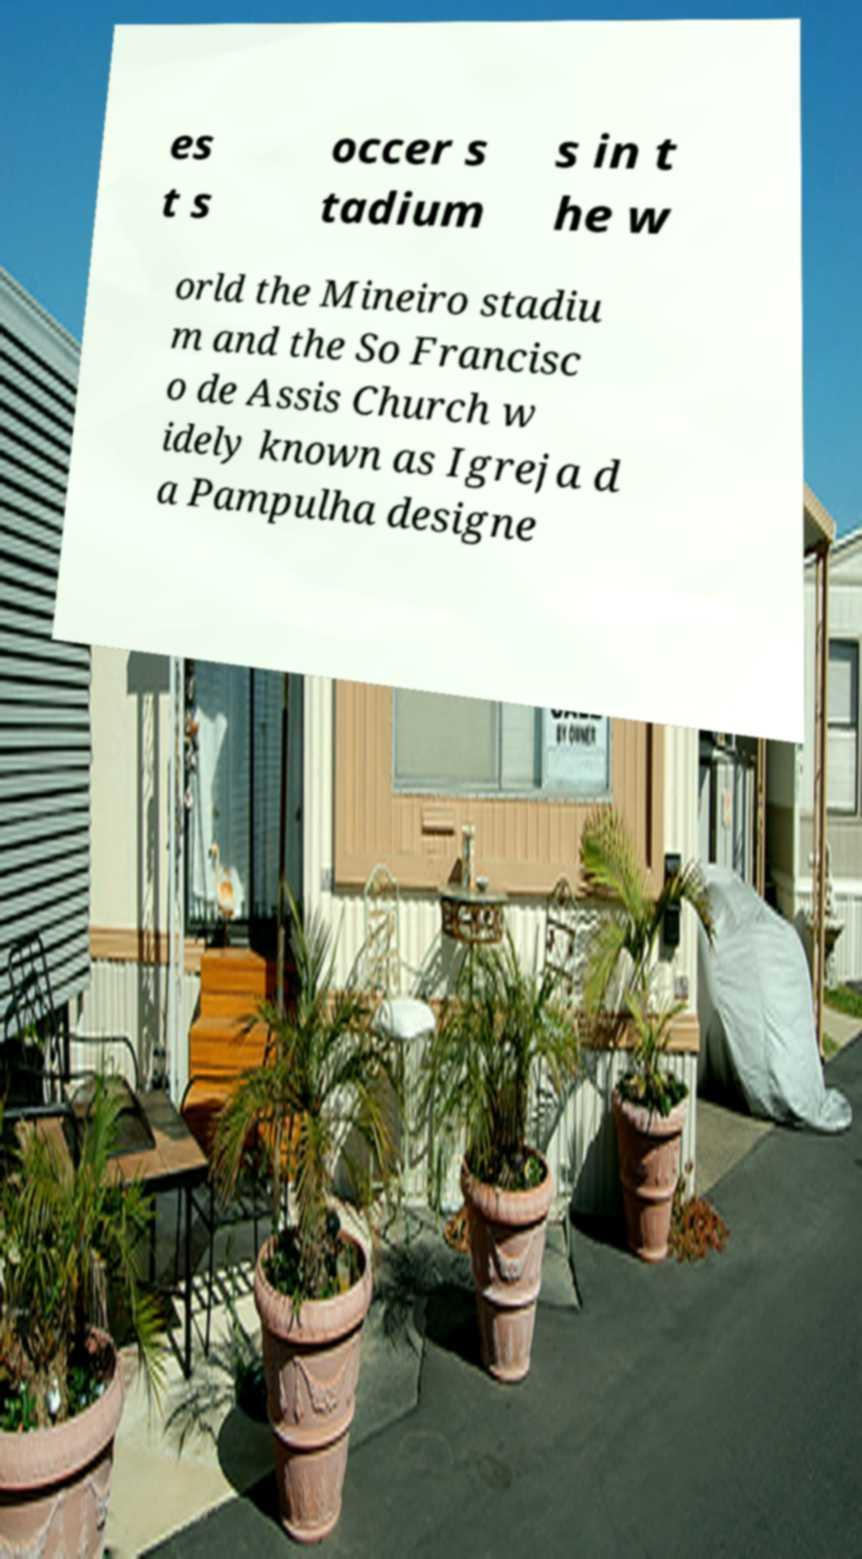Could you extract and type out the text from this image? es t s occer s tadium s in t he w orld the Mineiro stadiu m and the So Francisc o de Assis Church w idely known as Igreja d a Pampulha designe 